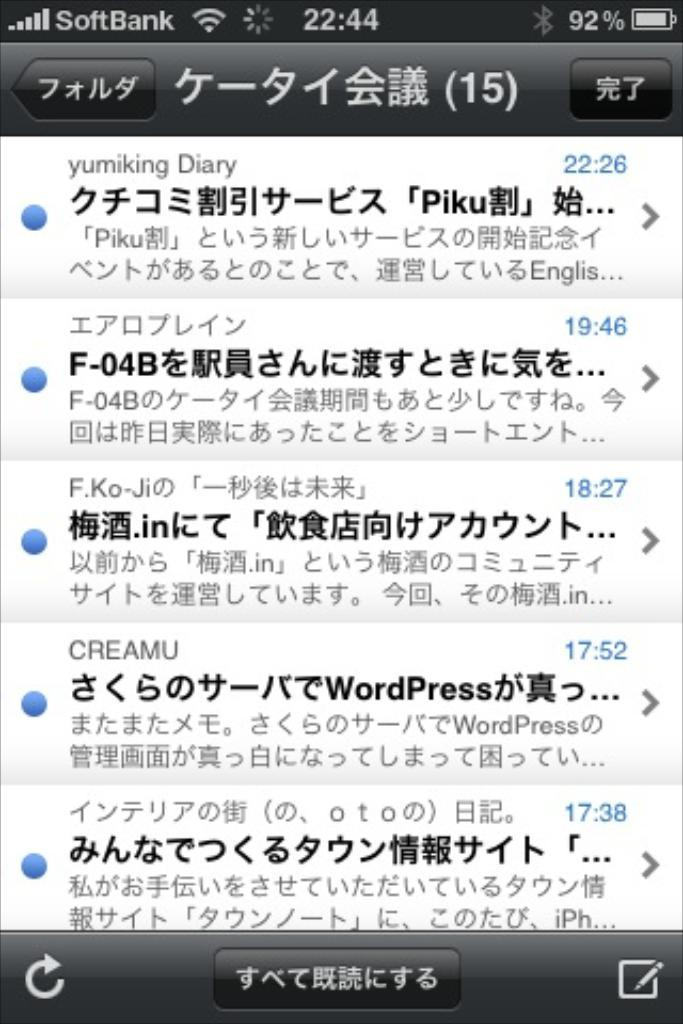<image>
Render a clear and concise summary of the photo. A phone screen full of Asian text as possible text messages. 